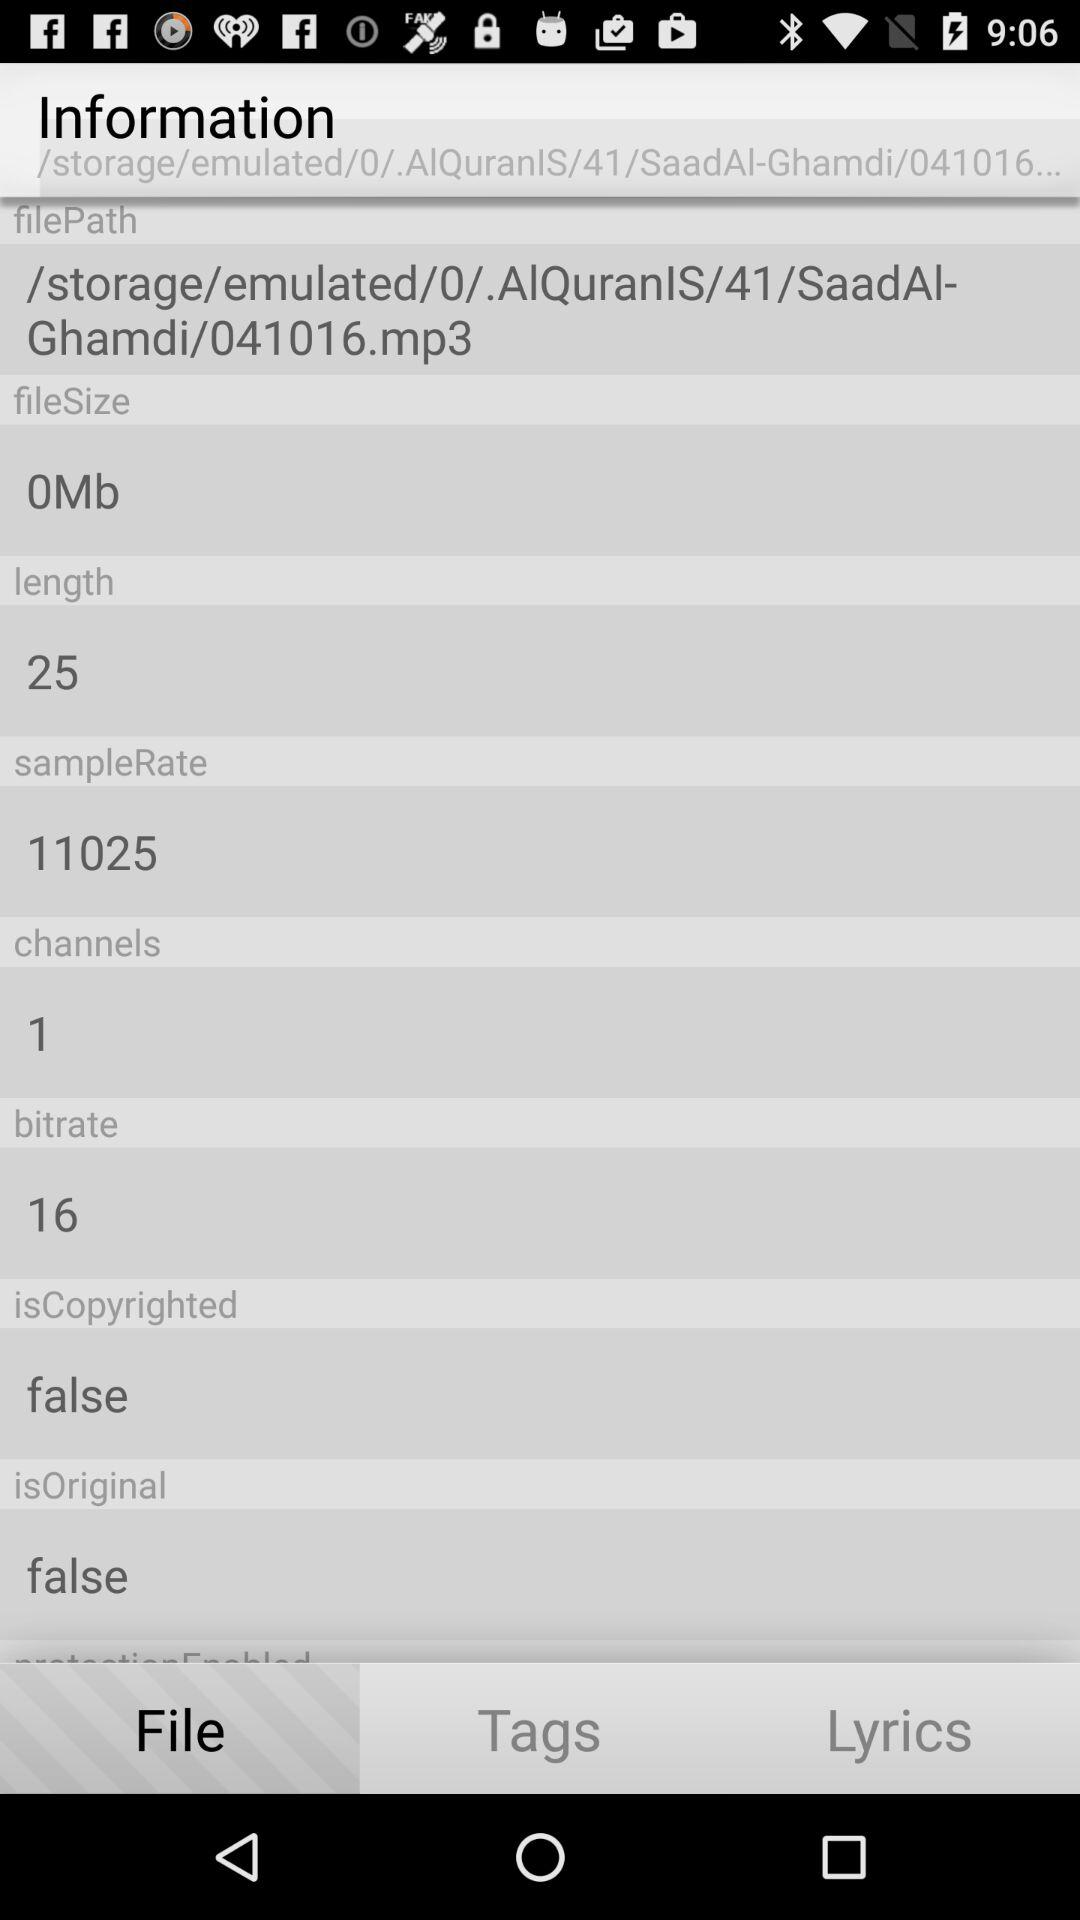How many channels are there? There is one channel. 